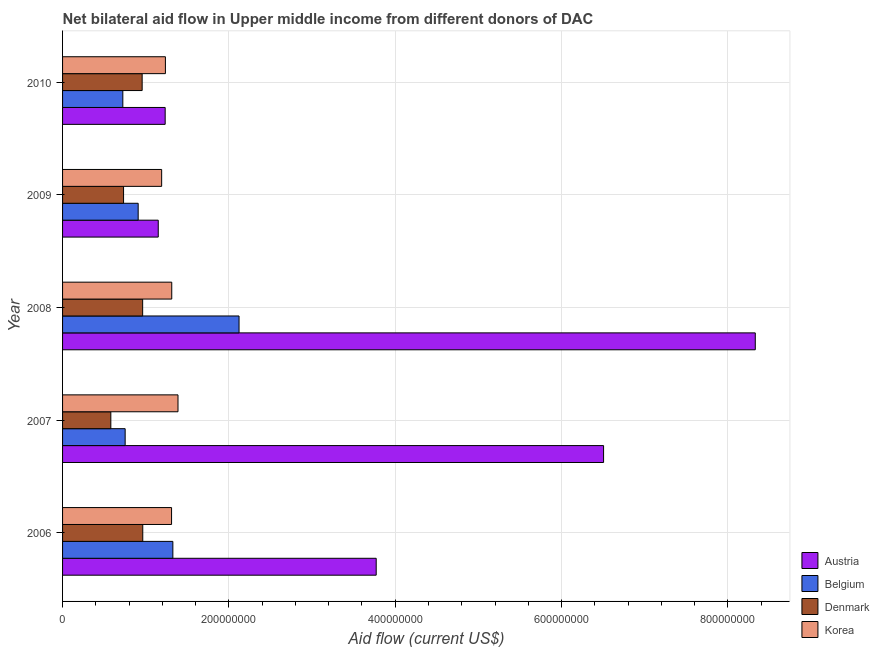How many different coloured bars are there?
Your response must be concise. 4. Are the number of bars per tick equal to the number of legend labels?
Keep it short and to the point. Yes. Are the number of bars on each tick of the Y-axis equal?
Give a very brief answer. Yes. How many bars are there on the 5th tick from the top?
Offer a terse response. 4. How many bars are there on the 5th tick from the bottom?
Offer a terse response. 4. In how many cases, is the number of bars for a given year not equal to the number of legend labels?
Offer a terse response. 0. What is the amount of aid given by korea in 2008?
Make the answer very short. 1.31e+08. Across all years, what is the maximum amount of aid given by korea?
Offer a terse response. 1.39e+08. Across all years, what is the minimum amount of aid given by austria?
Your answer should be very brief. 1.15e+08. In which year was the amount of aid given by belgium maximum?
Provide a succinct answer. 2008. What is the total amount of aid given by austria in the graph?
Give a very brief answer. 2.10e+09. What is the difference between the amount of aid given by austria in 2007 and that in 2009?
Your answer should be compact. 5.35e+08. What is the difference between the amount of aid given by denmark in 2007 and the amount of aid given by belgium in 2008?
Offer a terse response. -1.54e+08. What is the average amount of aid given by belgium per year?
Offer a terse response. 1.17e+08. In the year 2007, what is the difference between the amount of aid given by austria and amount of aid given by korea?
Your response must be concise. 5.12e+08. What is the ratio of the amount of aid given by denmark in 2006 to that in 2009?
Offer a terse response. 1.31. Is the difference between the amount of aid given by korea in 2008 and 2009 greater than the difference between the amount of aid given by belgium in 2008 and 2009?
Provide a short and direct response. No. What is the difference between the highest and the second highest amount of aid given by korea?
Your answer should be very brief. 7.50e+06. What is the difference between the highest and the lowest amount of aid given by korea?
Your answer should be very brief. 1.96e+07. Is the sum of the amount of aid given by belgium in 2008 and 2010 greater than the maximum amount of aid given by korea across all years?
Give a very brief answer. Yes. Is it the case that in every year, the sum of the amount of aid given by korea and amount of aid given by belgium is greater than the sum of amount of aid given by austria and amount of aid given by denmark?
Ensure brevity in your answer.  No. How many bars are there?
Keep it short and to the point. 20. Are the values on the major ticks of X-axis written in scientific E-notation?
Provide a succinct answer. No. What is the title of the graph?
Offer a terse response. Net bilateral aid flow in Upper middle income from different donors of DAC. What is the Aid flow (current US$) of Austria in 2006?
Keep it short and to the point. 3.77e+08. What is the Aid flow (current US$) in Belgium in 2006?
Your response must be concise. 1.33e+08. What is the Aid flow (current US$) in Denmark in 2006?
Ensure brevity in your answer.  9.64e+07. What is the Aid flow (current US$) of Korea in 2006?
Ensure brevity in your answer.  1.31e+08. What is the Aid flow (current US$) of Austria in 2007?
Your response must be concise. 6.50e+08. What is the Aid flow (current US$) of Belgium in 2007?
Keep it short and to the point. 7.52e+07. What is the Aid flow (current US$) of Denmark in 2007?
Your response must be concise. 5.80e+07. What is the Aid flow (current US$) in Korea in 2007?
Make the answer very short. 1.39e+08. What is the Aid flow (current US$) of Austria in 2008?
Ensure brevity in your answer.  8.33e+08. What is the Aid flow (current US$) in Belgium in 2008?
Provide a succinct answer. 2.12e+08. What is the Aid flow (current US$) of Denmark in 2008?
Provide a short and direct response. 9.63e+07. What is the Aid flow (current US$) of Korea in 2008?
Your response must be concise. 1.31e+08. What is the Aid flow (current US$) of Austria in 2009?
Make the answer very short. 1.15e+08. What is the Aid flow (current US$) of Belgium in 2009?
Your answer should be very brief. 9.09e+07. What is the Aid flow (current US$) of Denmark in 2009?
Offer a very short reply. 7.33e+07. What is the Aid flow (current US$) in Korea in 2009?
Your answer should be compact. 1.19e+08. What is the Aid flow (current US$) of Austria in 2010?
Offer a very short reply. 1.23e+08. What is the Aid flow (current US$) in Belgium in 2010?
Make the answer very short. 7.25e+07. What is the Aid flow (current US$) in Denmark in 2010?
Give a very brief answer. 9.57e+07. What is the Aid flow (current US$) of Korea in 2010?
Offer a terse response. 1.24e+08. Across all years, what is the maximum Aid flow (current US$) of Austria?
Your answer should be compact. 8.33e+08. Across all years, what is the maximum Aid flow (current US$) of Belgium?
Your answer should be very brief. 2.12e+08. Across all years, what is the maximum Aid flow (current US$) of Denmark?
Your answer should be compact. 9.64e+07. Across all years, what is the maximum Aid flow (current US$) of Korea?
Make the answer very short. 1.39e+08. Across all years, what is the minimum Aid flow (current US$) in Austria?
Make the answer very short. 1.15e+08. Across all years, what is the minimum Aid flow (current US$) in Belgium?
Make the answer very short. 7.25e+07. Across all years, what is the minimum Aid flow (current US$) in Denmark?
Your answer should be compact. 5.80e+07. Across all years, what is the minimum Aid flow (current US$) of Korea?
Give a very brief answer. 1.19e+08. What is the total Aid flow (current US$) in Austria in the graph?
Ensure brevity in your answer.  2.10e+09. What is the total Aid flow (current US$) of Belgium in the graph?
Make the answer very short. 5.83e+08. What is the total Aid flow (current US$) of Denmark in the graph?
Your response must be concise. 4.20e+08. What is the total Aid flow (current US$) in Korea in the graph?
Offer a very short reply. 6.44e+08. What is the difference between the Aid flow (current US$) in Austria in 2006 and that in 2007?
Provide a short and direct response. -2.73e+08. What is the difference between the Aid flow (current US$) of Belgium in 2006 and that in 2007?
Provide a succinct answer. 5.74e+07. What is the difference between the Aid flow (current US$) in Denmark in 2006 and that in 2007?
Provide a short and direct response. 3.84e+07. What is the difference between the Aid flow (current US$) in Korea in 2006 and that in 2007?
Your response must be concise. -7.73e+06. What is the difference between the Aid flow (current US$) of Austria in 2006 and that in 2008?
Your answer should be very brief. -4.56e+08. What is the difference between the Aid flow (current US$) in Belgium in 2006 and that in 2008?
Provide a succinct answer. -7.96e+07. What is the difference between the Aid flow (current US$) in Korea in 2006 and that in 2008?
Your answer should be very brief. -2.30e+05. What is the difference between the Aid flow (current US$) of Austria in 2006 and that in 2009?
Make the answer very short. 2.62e+08. What is the difference between the Aid flow (current US$) in Belgium in 2006 and that in 2009?
Your answer should be compact. 4.17e+07. What is the difference between the Aid flow (current US$) of Denmark in 2006 and that in 2009?
Provide a short and direct response. 2.31e+07. What is the difference between the Aid flow (current US$) of Korea in 2006 and that in 2009?
Give a very brief answer. 1.19e+07. What is the difference between the Aid flow (current US$) of Austria in 2006 and that in 2010?
Offer a very short reply. 2.54e+08. What is the difference between the Aid flow (current US$) of Belgium in 2006 and that in 2010?
Provide a succinct answer. 6.01e+07. What is the difference between the Aid flow (current US$) in Denmark in 2006 and that in 2010?
Keep it short and to the point. 7.20e+05. What is the difference between the Aid flow (current US$) of Korea in 2006 and that in 2010?
Give a very brief answer. 7.40e+06. What is the difference between the Aid flow (current US$) of Austria in 2007 and that in 2008?
Offer a very short reply. -1.82e+08. What is the difference between the Aid flow (current US$) in Belgium in 2007 and that in 2008?
Give a very brief answer. -1.37e+08. What is the difference between the Aid flow (current US$) of Denmark in 2007 and that in 2008?
Offer a terse response. -3.83e+07. What is the difference between the Aid flow (current US$) in Korea in 2007 and that in 2008?
Your answer should be compact. 7.50e+06. What is the difference between the Aid flow (current US$) of Austria in 2007 and that in 2009?
Offer a very short reply. 5.35e+08. What is the difference between the Aid flow (current US$) of Belgium in 2007 and that in 2009?
Offer a very short reply. -1.57e+07. What is the difference between the Aid flow (current US$) in Denmark in 2007 and that in 2009?
Give a very brief answer. -1.53e+07. What is the difference between the Aid flow (current US$) in Korea in 2007 and that in 2009?
Offer a very short reply. 1.96e+07. What is the difference between the Aid flow (current US$) in Austria in 2007 and that in 2010?
Your response must be concise. 5.27e+08. What is the difference between the Aid flow (current US$) of Belgium in 2007 and that in 2010?
Ensure brevity in your answer.  2.79e+06. What is the difference between the Aid flow (current US$) of Denmark in 2007 and that in 2010?
Make the answer very short. -3.77e+07. What is the difference between the Aid flow (current US$) of Korea in 2007 and that in 2010?
Make the answer very short. 1.51e+07. What is the difference between the Aid flow (current US$) in Austria in 2008 and that in 2009?
Ensure brevity in your answer.  7.18e+08. What is the difference between the Aid flow (current US$) of Belgium in 2008 and that in 2009?
Give a very brief answer. 1.21e+08. What is the difference between the Aid flow (current US$) of Denmark in 2008 and that in 2009?
Make the answer very short. 2.30e+07. What is the difference between the Aid flow (current US$) of Korea in 2008 and that in 2009?
Provide a succinct answer. 1.22e+07. What is the difference between the Aid flow (current US$) of Austria in 2008 and that in 2010?
Ensure brevity in your answer.  7.10e+08. What is the difference between the Aid flow (current US$) of Belgium in 2008 and that in 2010?
Ensure brevity in your answer.  1.40e+08. What is the difference between the Aid flow (current US$) of Denmark in 2008 and that in 2010?
Offer a very short reply. 5.90e+05. What is the difference between the Aid flow (current US$) in Korea in 2008 and that in 2010?
Ensure brevity in your answer.  7.63e+06. What is the difference between the Aid flow (current US$) in Austria in 2009 and that in 2010?
Give a very brief answer. -8.31e+06. What is the difference between the Aid flow (current US$) of Belgium in 2009 and that in 2010?
Your answer should be compact. 1.84e+07. What is the difference between the Aid flow (current US$) in Denmark in 2009 and that in 2010?
Make the answer very short. -2.24e+07. What is the difference between the Aid flow (current US$) in Korea in 2009 and that in 2010?
Provide a short and direct response. -4.52e+06. What is the difference between the Aid flow (current US$) of Austria in 2006 and the Aid flow (current US$) of Belgium in 2007?
Your response must be concise. 3.02e+08. What is the difference between the Aid flow (current US$) in Austria in 2006 and the Aid flow (current US$) in Denmark in 2007?
Offer a terse response. 3.19e+08. What is the difference between the Aid flow (current US$) in Austria in 2006 and the Aid flow (current US$) in Korea in 2007?
Make the answer very short. 2.38e+08. What is the difference between the Aid flow (current US$) of Belgium in 2006 and the Aid flow (current US$) of Denmark in 2007?
Your response must be concise. 7.46e+07. What is the difference between the Aid flow (current US$) in Belgium in 2006 and the Aid flow (current US$) in Korea in 2007?
Provide a short and direct response. -6.18e+06. What is the difference between the Aid flow (current US$) in Denmark in 2006 and the Aid flow (current US$) in Korea in 2007?
Provide a succinct answer. -4.24e+07. What is the difference between the Aid flow (current US$) of Austria in 2006 and the Aid flow (current US$) of Belgium in 2008?
Offer a very short reply. 1.65e+08. What is the difference between the Aid flow (current US$) in Austria in 2006 and the Aid flow (current US$) in Denmark in 2008?
Give a very brief answer. 2.81e+08. What is the difference between the Aid flow (current US$) of Austria in 2006 and the Aid flow (current US$) of Korea in 2008?
Keep it short and to the point. 2.46e+08. What is the difference between the Aid flow (current US$) of Belgium in 2006 and the Aid flow (current US$) of Denmark in 2008?
Make the answer very short. 3.63e+07. What is the difference between the Aid flow (current US$) of Belgium in 2006 and the Aid flow (current US$) of Korea in 2008?
Your answer should be very brief. 1.32e+06. What is the difference between the Aid flow (current US$) in Denmark in 2006 and the Aid flow (current US$) in Korea in 2008?
Your answer should be very brief. -3.49e+07. What is the difference between the Aid flow (current US$) in Austria in 2006 and the Aid flow (current US$) in Belgium in 2009?
Provide a succinct answer. 2.86e+08. What is the difference between the Aid flow (current US$) in Austria in 2006 and the Aid flow (current US$) in Denmark in 2009?
Provide a short and direct response. 3.04e+08. What is the difference between the Aid flow (current US$) in Austria in 2006 and the Aid flow (current US$) in Korea in 2009?
Provide a short and direct response. 2.58e+08. What is the difference between the Aid flow (current US$) of Belgium in 2006 and the Aid flow (current US$) of Denmark in 2009?
Keep it short and to the point. 5.93e+07. What is the difference between the Aid flow (current US$) in Belgium in 2006 and the Aid flow (current US$) in Korea in 2009?
Your answer should be compact. 1.35e+07. What is the difference between the Aid flow (current US$) of Denmark in 2006 and the Aid flow (current US$) of Korea in 2009?
Provide a succinct answer. -2.27e+07. What is the difference between the Aid flow (current US$) in Austria in 2006 and the Aid flow (current US$) in Belgium in 2010?
Give a very brief answer. 3.05e+08. What is the difference between the Aid flow (current US$) in Austria in 2006 and the Aid flow (current US$) in Denmark in 2010?
Give a very brief answer. 2.81e+08. What is the difference between the Aid flow (current US$) in Austria in 2006 and the Aid flow (current US$) in Korea in 2010?
Make the answer very short. 2.53e+08. What is the difference between the Aid flow (current US$) in Belgium in 2006 and the Aid flow (current US$) in Denmark in 2010?
Provide a short and direct response. 3.69e+07. What is the difference between the Aid flow (current US$) of Belgium in 2006 and the Aid flow (current US$) of Korea in 2010?
Your answer should be very brief. 8.95e+06. What is the difference between the Aid flow (current US$) in Denmark in 2006 and the Aid flow (current US$) in Korea in 2010?
Provide a succinct answer. -2.72e+07. What is the difference between the Aid flow (current US$) in Austria in 2007 and the Aid flow (current US$) in Belgium in 2008?
Your answer should be very brief. 4.38e+08. What is the difference between the Aid flow (current US$) of Austria in 2007 and the Aid flow (current US$) of Denmark in 2008?
Your response must be concise. 5.54e+08. What is the difference between the Aid flow (current US$) of Austria in 2007 and the Aid flow (current US$) of Korea in 2008?
Provide a succinct answer. 5.19e+08. What is the difference between the Aid flow (current US$) of Belgium in 2007 and the Aid flow (current US$) of Denmark in 2008?
Keep it short and to the point. -2.10e+07. What is the difference between the Aid flow (current US$) of Belgium in 2007 and the Aid flow (current US$) of Korea in 2008?
Provide a short and direct response. -5.60e+07. What is the difference between the Aid flow (current US$) in Denmark in 2007 and the Aid flow (current US$) in Korea in 2008?
Offer a terse response. -7.32e+07. What is the difference between the Aid flow (current US$) of Austria in 2007 and the Aid flow (current US$) of Belgium in 2009?
Provide a short and direct response. 5.60e+08. What is the difference between the Aid flow (current US$) in Austria in 2007 and the Aid flow (current US$) in Denmark in 2009?
Keep it short and to the point. 5.77e+08. What is the difference between the Aid flow (current US$) in Austria in 2007 and the Aid flow (current US$) in Korea in 2009?
Keep it short and to the point. 5.31e+08. What is the difference between the Aid flow (current US$) of Belgium in 2007 and the Aid flow (current US$) of Denmark in 2009?
Offer a very short reply. 1.92e+06. What is the difference between the Aid flow (current US$) in Belgium in 2007 and the Aid flow (current US$) in Korea in 2009?
Make the answer very short. -4.39e+07. What is the difference between the Aid flow (current US$) of Denmark in 2007 and the Aid flow (current US$) of Korea in 2009?
Offer a very short reply. -6.11e+07. What is the difference between the Aid flow (current US$) in Austria in 2007 and the Aid flow (current US$) in Belgium in 2010?
Make the answer very short. 5.78e+08. What is the difference between the Aid flow (current US$) in Austria in 2007 and the Aid flow (current US$) in Denmark in 2010?
Your answer should be very brief. 5.55e+08. What is the difference between the Aid flow (current US$) in Austria in 2007 and the Aid flow (current US$) in Korea in 2010?
Your answer should be very brief. 5.27e+08. What is the difference between the Aid flow (current US$) of Belgium in 2007 and the Aid flow (current US$) of Denmark in 2010?
Make the answer very short. -2.04e+07. What is the difference between the Aid flow (current US$) in Belgium in 2007 and the Aid flow (current US$) in Korea in 2010?
Your response must be concise. -4.84e+07. What is the difference between the Aid flow (current US$) of Denmark in 2007 and the Aid flow (current US$) of Korea in 2010?
Your answer should be compact. -6.56e+07. What is the difference between the Aid flow (current US$) in Austria in 2008 and the Aid flow (current US$) in Belgium in 2009?
Ensure brevity in your answer.  7.42e+08. What is the difference between the Aid flow (current US$) in Austria in 2008 and the Aid flow (current US$) in Denmark in 2009?
Provide a succinct answer. 7.60e+08. What is the difference between the Aid flow (current US$) in Austria in 2008 and the Aid flow (current US$) in Korea in 2009?
Offer a terse response. 7.14e+08. What is the difference between the Aid flow (current US$) in Belgium in 2008 and the Aid flow (current US$) in Denmark in 2009?
Offer a terse response. 1.39e+08. What is the difference between the Aid flow (current US$) of Belgium in 2008 and the Aid flow (current US$) of Korea in 2009?
Your answer should be very brief. 9.30e+07. What is the difference between the Aid flow (current US$) in Denmark in 2008 and the Aid flow (current US$) in Korea in 2009?
Your answer should be compact. -2.28e+07. What is the difference between the Aid flow (current US$) in Austria in 2008 and the Aid flow (current US$) in Belgium in 2010?
Your response must be concise. 7.60e+08. What is the difference between the Aid flow (current US$) in Austria in 2008 and the Aid flow (current US$) in Denmark in 2010?
Provide a succinct answer. 7.37e+08. What is the difference between the Aid flow (current US$) of Austria in 2008 and the Aid flow (current US$) of Korea in 2010?
Offer a very short reply. 7.09e+08. What is the difference between the Aid flow (current US$) in Belgium in 2008 and the Aid flow (current US$) in Denmark in 2010?
Your response must be concise. 1.16e+08. What is the difference between the Aid flow (current US$) of Belgium in 2008 and the Aid flow (current US$) of Korea in 2010?
Your response must be concise. 8.85e+07. What is the difference between the Aid flow (current US$) in Denmark in 2008 and the Aid flow (current US$) in Korea in 2010?
Provide a succinct answer. -2.74e+07. What is the difference between the Aid flow (current US$) in Austria in 2009 and the Aid flow (current US$) in Belgium in 2010?
Ensure brevity in your answer.  4.26e+07. What is the difference between the Aid flow (current US$) of Austria in 2009 and the Aid flow (current US$) of Denmark in 2010?
Your answer should be compact. 1.94e+07. What is the difference between the Aid flow (current US$) of Austria in 2009 and the Aid flow (current US$) of Korea in 2010?
Your answer should be compact. -8.60e+06. What is the difference between the Aid flow (current US$) in Belgium in 2009 and the Aid flow (current US$) in Denmark in 2010?
Provide a succinct answer. -4.79e+06. What is the difference between the Aid flow (current US$) in Belgium in 2009 and the Aid flow (current US$) in Korea in 2010?
Provide a short and direct response. -3.27e+07. What is the difference between the Aid flow (current US$) in Denmark in 2009 and the Aid flow (current US$) in Korea in 2010?
Your answer should be very brief. -5.03e+07. What is the average Aid flow (current US$) in Austria per year?
Ensure brevity in your answer.  4.20e+08. What is the average Aid flow (current US$) in Belgium per year?
Ensure brevity in your answer.  1.17e+08. What is the average Aid flow (current US$) in Denmark per year?
Your response must be concise. 8.40e+07. What is the average Aid flow (current US$) of Korea per year?
Ensure brevity in your answer.  1.29e+08. In the year 2006, what is the difference between the Aid flow (current US$) of Austria and Aid flow (current US$) of Belgium?
Give a very brief answer. 2.44e+08. In the year 2006, what is the difference between the Aid flow (current US$) in Austria and Aid flow (current US$) in Denmark?
Ensure brevity in your answer.  2.81e+08. In the year 2006, what is the difference between the Aid flow (current US$) in Austria and Aid flow (current US$) in Korea?
Your response must be concise. 2.46e+08. In the year 2006, what is the difference between the Aid flow (current US$) of Belgium and Aid flow (current US$) of Denmark?
Make the answer very short. 3.62e+07. In the year 2006, what is the difference between the Aid flow (current US$) in Belgium and Aid flow (current US$) in Korea?
Your answer should be very brief. 1.55e+06. In the year 2006, what is the difference between the Aid flow (current US$) in Denmark and Aid flow (current US$) in Korea?
Offer a terse response. -3.46e+07. In the year 2007, what is the difference between the Aid flow (current US$) in Austria and Aid flow (current US$) in Belgium?
Your response must be concise. 5.75e+08. In the year 2007, what is the difference between the Aid flow (current US$) of Austria and Aid flow (current US$) of Denmark?
Give a very brief answer. 5.92e+08. In the year 2007, what is the difference between the Aid flow (current US$) of Austria and Aid flow (current US$) of Korea?
Your answer should be compact. 5.12e+08. In the year 2007, what is the difference between the Aid flow (current US$) in Belgium and Aid flow (current US$) in Denmark?
Your response must be concise. 1.72e+07. In the year 2007, what is the difference between the Aid flow (current US$) of Belgium and Aid flow (current US$) of Korea?
Your answer should be very brief. -6.35e+07. In the year 2007, what is the difference between the Aid flow (current US$) of Denmark and Aid flow (current US$) of Korea?
Offer a terse response. -8.08e+07. In the year 2008, what is the difference between the Aid flow (current US$) in Austria and Aid flow (current US$) in Belgium?
Offer a very short reply. 6.21e+08. In the year 2008, what is the difference between the Aid flow (current US$) in Austria and Aid flow (current US$) in Denmark?
Your response must be concise. 7.37e+08. In the year 2008, what is the difference between the Aid flow (current US$) in Austria and Aid flow (current US$) in Korea?
Your answer should be very brief. 7.02e+08. In the year 2008, what is the difference between the Aid flow (current US$) in Belgium and Aid flow (current US$) in Denmark?
Your answer should be compact. 1.16e+08. In the year 2008, what is the difference between the Aid flow (current US$) in Belgium and Aid flow (current US$) in Korea?
Give a very brief answer. 8.09e+07. In the year 2008, what is the difference between the Aid flow (current US$) in Denmark and Aid flow (current US$) in Korea?
Provide a short and direct response. -3.50e+07. In the year 2009, what is the difference between the Aid flow (current US$) of Austria and Aid flow (current US$) of Belgium?
Offer a terse response. 2.41e+07. In the year 2009, what is the difference between the Aid flow (current US$) of Austria and Aid flow (current US$) of Denmark?
Ensure brevity in your answer.  4.17e+07. In the year 2009, what is the difference between the Aid flow (current US$) of Austria and Aid flow (current US$) of Korea?
Your response must be concise. -4.08e+06. In the year 2009, what is the difference between the Aid flow (current US$) in Belgium and Aid flow (current US$) in Denmark?
Keep it short and to the point. 1.76e+07. In the year 2009, what is the difference between the Aid flow (current US$) of Belgium and Aid flow (current US$) of Korea?
Make the answer very short. -2.82e+07. In the year 2009, what is the difference between the Aid flow (current US$) of Denmark and Aid flow (current US$) of Korea?
Offer a terse response. -4.58e+07. In the year 2010, what is the difference between the Aid flow (current US$) in Austria and Aid flow (current US$) in Belgium?
Your response must be concise. 5.09e+07. In the year 2010, what is the difference between the Aid flow (current US$) in Austria and Aid flow (current US$) in Denmark?
Your response must be concise. 2.77e+07. In the year 2010, what is the difference between the Aid flow (current US$) of Belgium and Aid flow (current US$) of Denmark?
Make the answer very short. -2.32e+07. In the year 2010, what is the difference between the Aid flow (current US$) in Belgium and Aid flow (current US$) in Korea?
Give a very brief answer. -5.12e+07. In the year 2010, what is the difference between the Aid flow (current US$) of Denmark and Aid flow (current US$) of Korea?
Your answer should be very brief. -2.80e+07. What is the ratio of the Aid flow (current US$) of Austria in 2006 to that in 2007?
Give a very brief answer. 0.58. What is the ratio of the Aid flow (current US$) of Belgium in 2006 to that in 2007?
Your response must be concise. 1.76. What is the ratio of the Aid flow (current US$) of Denmark in 2006 to that in 2007?
Offer a very short reply. 1.66. What is the ratio of the Aid flow (current US$) in Korea in 2006 to that in 2007?
Give a very brief answer. 0.94. What is the ratio of the Aid flow (current US$) of Austria in 2006 to that in 2008?
Make the answer very short. 0.45. What is the ratio of the Aid flow (current US$) in Belgium in 2006 to that in 2008?
Give a very brief answer. 0.62. What is the ratio of the Aid flow (current US$) of Denmark in 2006 to that in 2008?
Your answer should be very brief. 1. What is the ratio of the Aid flow (current US$) in Korea in 2006 to that in 2008?
Keep it short and to the point. 1. What is the ratio of the Aid flow (current US$) in Austria in 2006 to that in 2009?
Your response must be concise. 3.28. What is the ratio of the Aid flow (current US$) of Belgium in 2006 to that in 2009?
Ensure brevity in your answer.  1.46. What is the ratio of the Aid flow (current US$) in Denmark in 2006 to that in 2009?
Give a very brief answer. 1.31. What is the ratio of the Aid flow (current US$) in Korea in 2006 to that in 2009?
Ensure brevity in your answer.  1.1. What is the ratio of the Aid flow (current US$) in Austria in 2006 to that in 2010?
Provide a short and direct response. 3.06. What is the ratio of the Aid flow (current US$) of Belgium in 2006 to that in 2010?
Give a very brief answer. 1.83. What is the ratio of the Aid flow (current US$) of Denmark in 2006 to that in 2010?
Your answer should be very brief. 1.01. What is the ratio of the Aid flow (current US$) of Korea in 2006 to that in 2010?
Keep it short and to the point. 1.06. What is the ratio of the Aid flow (current US$) of Austria in 2007 to that in 2008?
Your answer should be very brief. 0.78. What is the ratio of the Aid flow (current US$) of Belgium in 2007 to that in 2008?
Offer a very short reply. 0.35. What is the ratio of the Aid flow (current US$) of Denmark in 2007 to that in 2008?
Ensure brevity in your answer.  0.6. What is the ratio of the Aid flow (current US$) in Korea in 2007 to that in 2008?
Your response must be concise. 1.06. What is the ratio of the Aid flow (current US$) of Austria in 2007 to that in 2009?
Offer a terse response. 5.65. What is the ratio of the Aid flow (current US$) in Belgium in 2007 to that in 2009?
Offer a very short reply. 0.83. What is the ratio of the Aid flow (current US$) of Denmark in 2007 to that in 2009?
Your answer should be compact. 0.79. What is the ratio of the Aid flow (current US$) in Korea in 2007 to that in 2009?
Your answer should be very brief. 1.16. What is the ratio of the Aid flow (current US$) in Austria in 2007 to that in 2010?
Provide a short and direct response. 5.27. What is the ratio of the Aid flow (current US$) in Denmark in 2007 to that in 2010?
Your response must be concise. 0.61. What is the ratio of the Aid flow (current US$) in Korea in 2007 to that in 2010?
Offer a very short reply. 1.12. What is the ratio of the Aid flow (current US$) of Austria in 2008 to that in 2009?
Make the answer very short. 7.24. What is the ratio of the Aid flow (current US$) of Belgium in 2008 to that in 2009?
Offer a terse response. 2.33. What is the ratio of the Aid flow (current US$) of Denmark in 2008 to that in 2009?
Your answer should be compact. 1.31. What is the ratio of the Aid flow (current US$) in Korea in 2008 to that in 2009?
Your response must be concise. 1.1. What is the ratio of the Aid flow (current US$) of Austria in 2008 to that in 2010?
Make the answer very short. 6.75. What is the ratio of the Aid flow (current US$) of Belgium in 2008 to that in 2010?
Your response must be concise. 2.93. What is the ratio of the Aid flow (current US$) in Korea in 2008 to that in 2010?
Give a very brief answer. 1.06. What is the ratio of the Aid flow (current US$) in Austria in 2009 to that in 2010?
Provide a short and direct response. 0.93. What is the ratio of the Aid flow (current US$) in Belgium in 2009 to that in 2010?
Ensure brevity in your answer.  1.25. What is the ratio of the Aid flow (current US$) of Denmark in 2009 to that in 2010?
Ensure brevity in your answer.  0.77. What is the ratio of the Aid flow (current US$) of Korea in 2009 to that in 2010?
Ensure brevity in your answer.  0.96. What is the difference between the highest and the second highest Aid flow (current US$) of Austria?
Offer a terse response. 1.82e+08. What is the difference between the highest and the second highest Aid flow (current US$) in Belgium?
Your answer should be very brief. 7.96e+07. What is the difference between the highest and the second highest Aid flow (current US$) in Korea?
Give a very brief answer. 7.50e+06. What is the difference between the highest and the lowest Aid flow (current US$) of Austria?
Provide a short and direct response. 7.18e+08. What is the difference between the highest and the lowest Aid flow (current US$) in Belgium?
Offer a terse response. 1.40e+08. What is the difference between the highest and the lowest Aid flow (current US$) in Denmark?
Ensure brevity in your answer.  3.84e+07. What is the difference between the highest and the lowest Aid flow (current US$) in Korea?
Keep it short and to the point. 1.96e+07. 